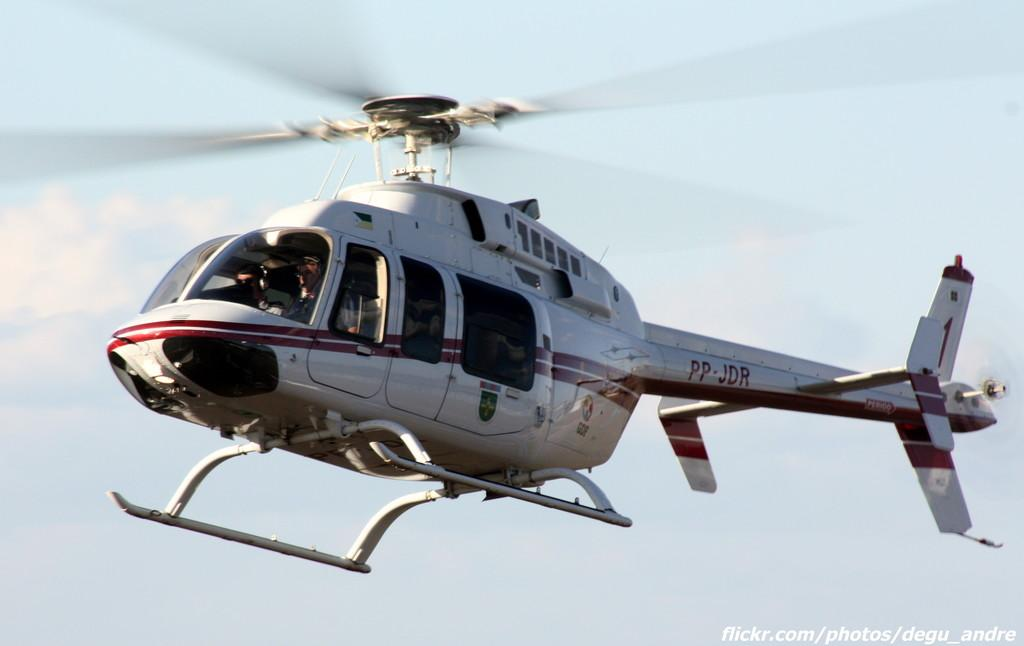<image>
Create a compact narrative representing the image presented. Helicopter number PP - JDR is in the sky. 